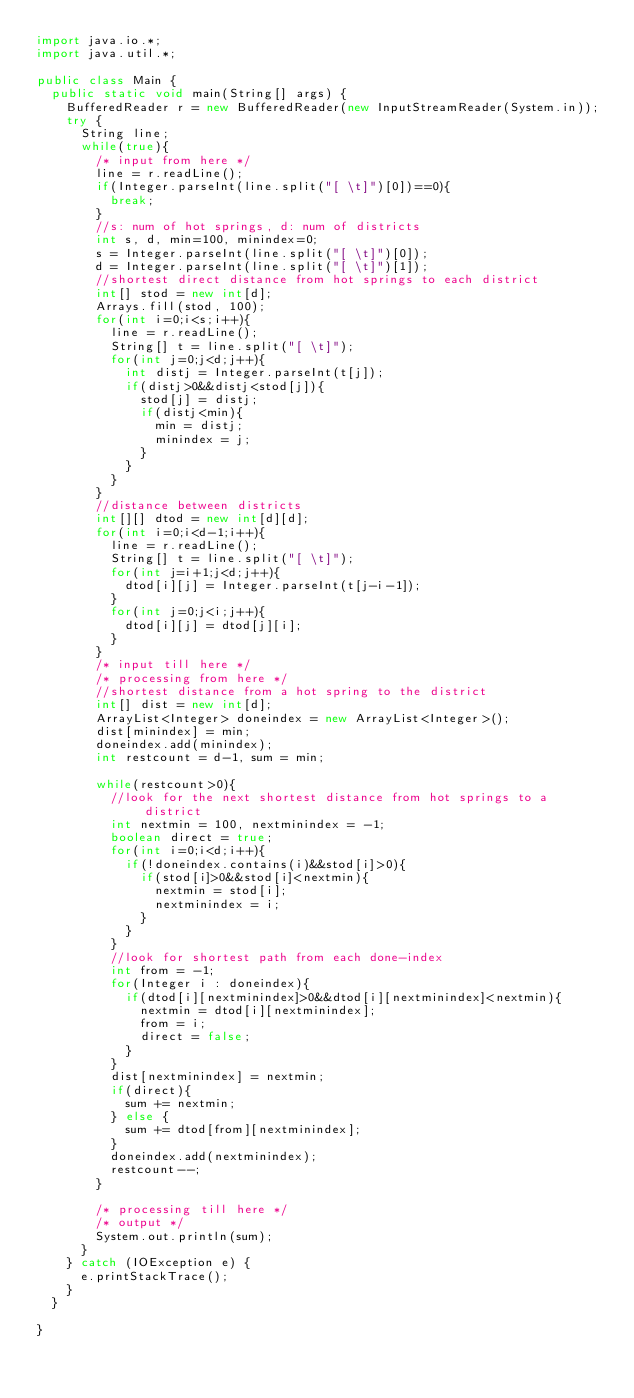<code> <loc_0><loc_0><loc_500><loc_500><_Java_>import java.io.*;
import java.util.*;

public class Main {
	public static void main(String[] args) {
		BufferedReader r = new BufferedReader(new InputStreamReader(System.in));       
		try {
			String line;
			while(true){
				/* input from here */
				line = r.readLine();
				if(Integer.parseInt(line.split("[ \t]")[0])==0){
					break;
				}
				//s: num of hot springs, d: num of districts
				int s, d, min=100, minindex=0;
				s = Integer.parseInt(line.split("[ \t]")[0]);
				d = Integer.parseInt(line.split("[ \t]")[1]);
				//shortest direct distance from hot springs to each district
				int[] stod = new int[d];
				Arrays.fill(stod, 100);
				for(int i=0;i<s;i++){
					line = r.readLine();
					String[] t = line.split("[ \t]");
					for(int j=0;j<d;j++){
						int distj = Integer.parseInt(t[j]);
						if(distj>0&&distj<stod[j]){
							stod[j] = distj;
							if(distj<min){
								min = distj;
								minindex = j;
							}
						}
					}
				}
				//distance between districts
				int[][] dtod = new int[d][d];
				for(int i=0;i<d-1;i++){
					line = r.readLine();
					String[] t = line.split("[ \t]");
					for(int j=i+1;j<d;j++){
						dtod[i][j] = Integer.parseInt(t[j-i-1]);
					}
					for(int j=0;j<i;j++){
						dtod[i][j] = dtod[j][i];
					}
				}				
				/* input till here */
				/* processing from here */
				//shortest distance from a hot spring to the district 
				int[] dist = new int[d];
				ArrayList<Integer> doneindex = new ArrayList<Integer>();
				dist[minindex] = min;
				doneindex.add(minindex);
				int restcount = d-1, sum = min;

				while(restcount>0){
					//look for the next shortest distance from hot springs to a district
					int nextmin = 100, nextminindex = -1;
					boolean direct = true;
					for(int i=0;i<d;i++){
						if(!doneindex.contains(i)&&stod[i]>0){
							if(stod[i]>0&&stod[i]<nextmin){
								nextmin = stod[i];
								nextminindex = i;
							}
						}
					}
					//look for shortest path from each done-index
					int from = -1;
					for(Integer i : doneindex){
						if(dtod[i][nextminindex]>0&&dtod[i][nextminindex]<nextmin){
							nextmin = dtod[i][nextminindex];
							from = i;
							direct = false;
						}
					}
					dist[nextminindex] = nextmin;
					if(direct){
						sum += nextmin;
					} else {
						sum += dtod[from][nextminindex];
					}
					doneindex.add(nextminindex);
					restcount--;
				}

				/* processing till here */
				/* output */
				System.out.println(sum);
			}
		} catch (IOException e) {
			e.printStackTrace();
		}
	}

}</code> 